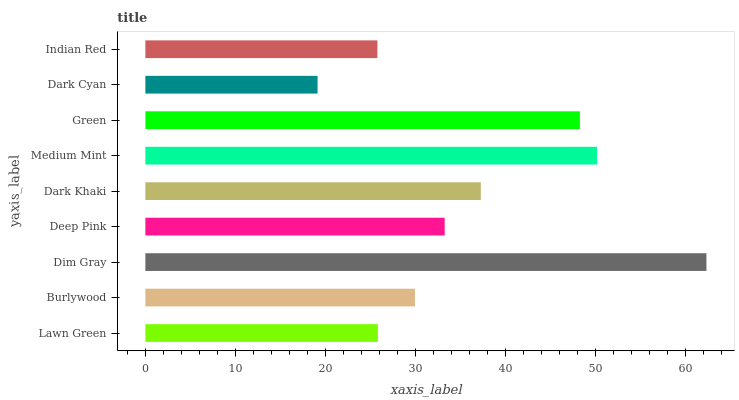Is Dark Cyan the minimum?
Answer yes or no. Yes. Is Dim Gray the maximum?
Answer yes or no. Yes. Is Burlywood the minimum?
Answer yes or no. No. Is Burlywood the maximum?
Answer yes or no. No. Is Burlywood greater than Lawn Green?
Answer yes or no. Yes. Is Lawn Green less than Burlywood?
Answer yes or no. Yes. Is Lawn Green greater than Burlywood?
Answer yes or no. No. Is Burlywood less than Lawn Green?
Answer yes or no. No. Is Deep Pink the high median?
Answer yes or no. Yes. Is Deep Pink the low median?
Answer yes or no. Yes. Is Dark Cyan the high median?
Answer yes or no. No. Is Dim Gray the low median?
Answer yes or no. No. 